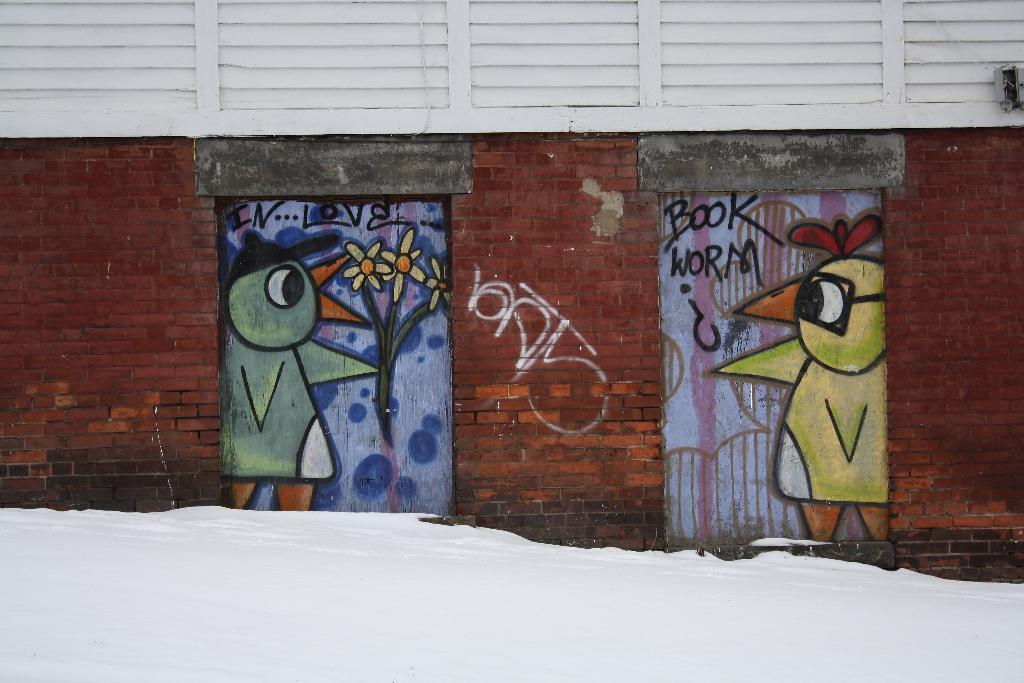Please provide a concise description of this image. In this picture we can see doors with painting on it, here we can see a wall. 